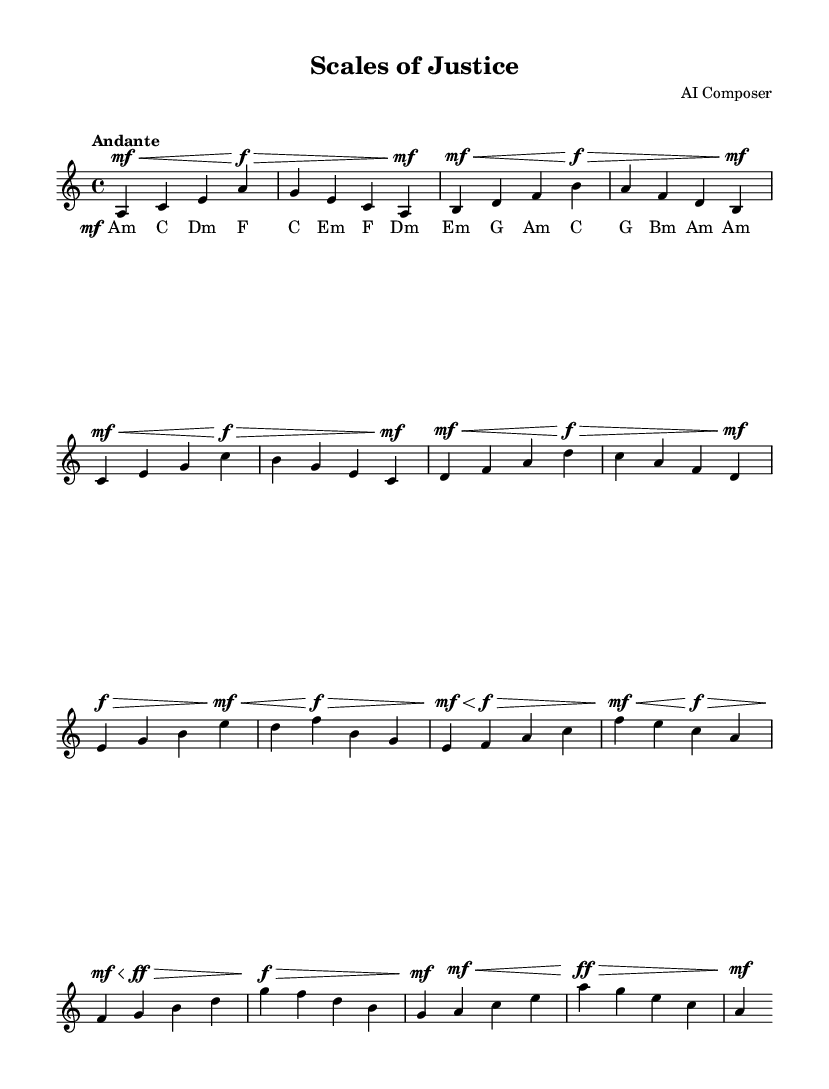What is the time signature of this music? The time signature is indicated at the beginning of the piece. It shows 4 beats per measure, which is a common time signature.
Answer: 4/4 What key is this piece written in? The key signature at the beginning shows A minor, which includes no sharps or flats.
Answer: A minor What is the tempo marking given for this piece? The tempo marking is found at the beginning and states "Andante," which indicates a moderately slow tempo.
Answer: Andante How many measures are there in this piece? By counting the individual measures displayed in the music, there are a total of 12 measures.
Answer: 12 What is the dynamic marking of the first measure? Looking at the first measure, the dynamic marking is marked as "mf" (mezzo forte), indicating a medium loudness.
Answer: mf What is the last chord in the score? The final chord is indicated in the last measure, where it shows "Am," representing an A minor chord.
Answer: Am 